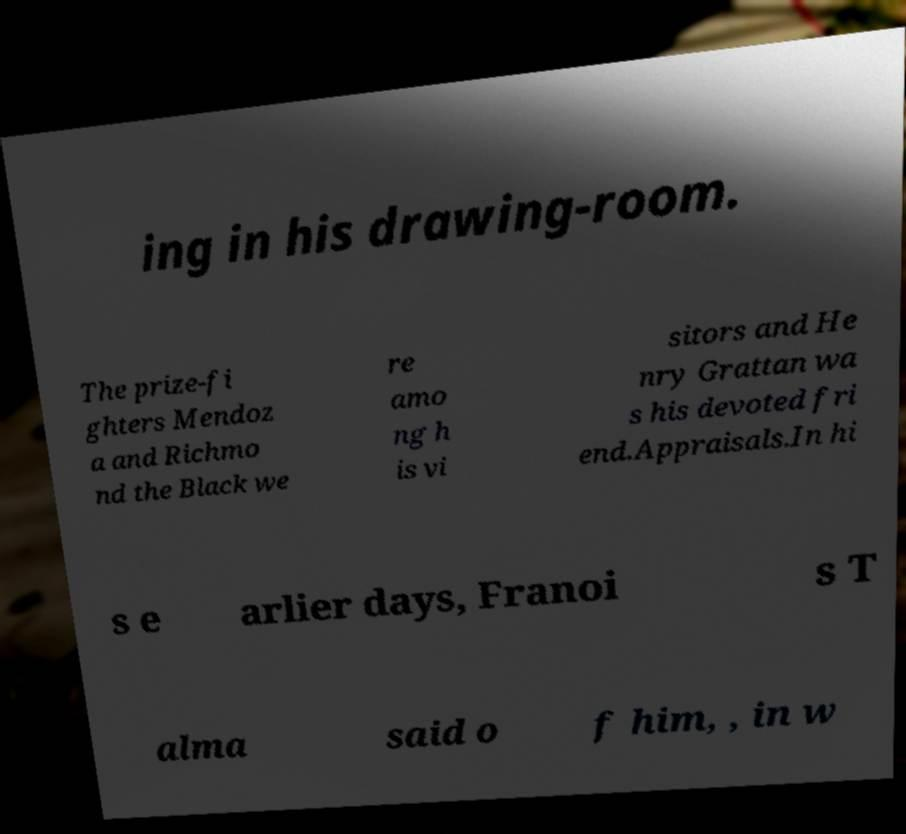Could you assist in decoding the text presented in this image and type it out clearly? ing in his drawing-room. The prize-fi ghters Mendoz a and Richmo nd the Black we re amo ng h is vi sitors and He nry Grattan wa s his devoted fri end.Appraisals.In hi s e arlier days, Franoi s T alma said o f him, , in w 